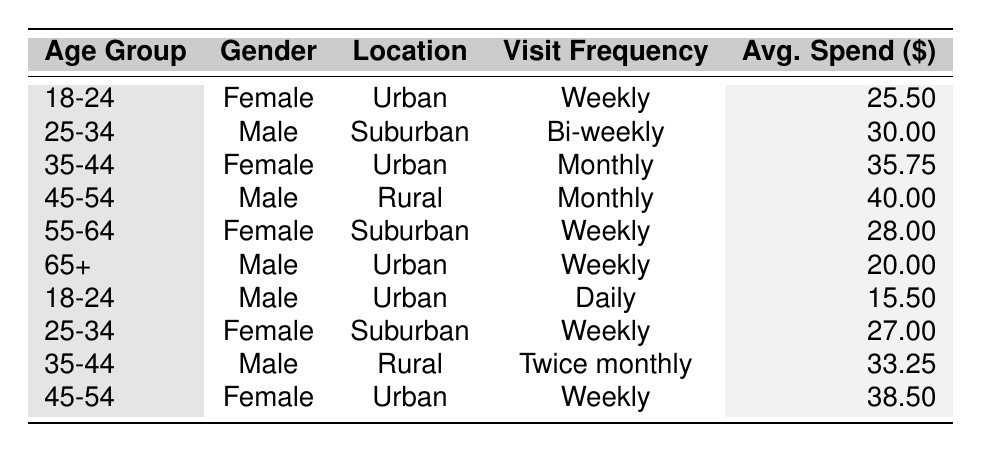What is the average spend of customers in the 25-34 age group? There are two entries in the 25-34 age group: one male spends $30.00 and one female spends $27.00. The average is calculated by adding these two amounts (30.00 + 27.00 = 57.00) and dividing by 2, resulting in an average spend of $28.50.
Answer: 28.50 How many visitors in the table are from urban locations? The entries from urban locations are: 18-24 Female, 35-44 Female, 65+ Male, 18-24 Male, and 45-54 Female. This totals 5 visitors from urban locations.
Answer: 5 Is there a female customer aged 55-64 in the table? The table lists customers aged 55-64, and it shows one female customer, confirming the presence of a female customer in this age group.
Answer: Yes What is the total average spend of all customers listed in the table? To find the total average spend, add all average spends: (25.50 + 30.00 + 35.75 + 40.00 + 28.00 + 20.00 + 15.50 + 27.00 + 33.25 + 38.50) =  365.50, then divide by 10 (the number of customers), yielding an average of $36.55.
Answer: 36.55 Which age group has the highest average spend and what is it? Review the average spends for each age group: 18-24 is $25.50, 25-34 is $28.50, 35-44 is $34.50, 45-54 is $39.25, 55-64 is $28.00, and 65+ is $20.00. The highest is in the 45-54 age group with an average spend of $39.25.
Answer: 45-54; 39.25 How many male visitors have a visit frequency of 'Weekly'? The male visitors with 'Weekly' visit frequency are: 65+ Male, 25-34 Female, and 45-54 Male for a total of 3 male customers.
Answer: 3 What is the difference in average spend between the youngest and oldest age groups? The average spend for the 18-24 age group is $25.50, and for the 65+ age group it is $20.00. The difference is $25.50 - $20.00 = $5.50.
Answer: 5.50 Which gender has a higher average spend in the 35-44 age group? In the 35-44 age group, the female spends $35.75 while the male spends $33.25. Therefore, the female has a higher average spend.
Answer: Female Are there more female customers than male customers in the table? Counting the customers: there are 5 female customers (18-24, 35-44, 55-64, 25-34, and 45-54) and 5 male customers (25-34, 45-54, 65+, 18-24, and 35-44). The numbers are equal.
Answer: No Which age group has the lowest average spend and what is that amount? The age group with the lowest average spend is 65+ with an average of $20.00.
Answer: 65+; 20.00 